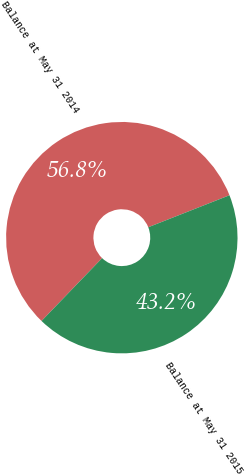<chart> <loc_0><loc_0><loc_500><loc_500><pie_chart><fcel>Balance at May 31 2014<fcel>Balance at May 31 2015<nl><fcel>56.82%<fcel>43.18%<nl></chart> 